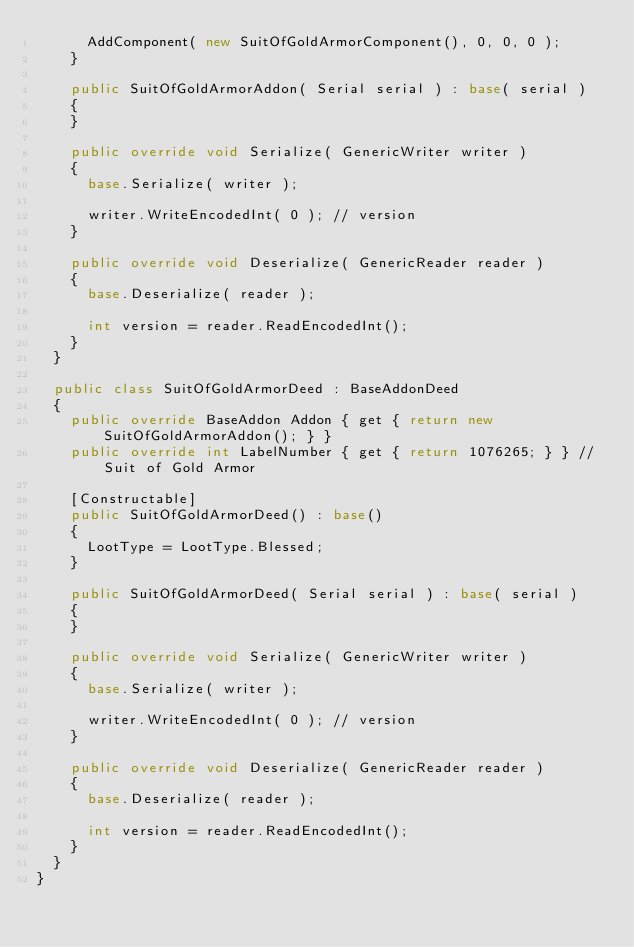<code> <loc_0><loc_0><loc_500><loc_500><_C#_>			AddComponent( new SuitOfGoldArmorComponent(), 0, 0, 0 );
		}

		public SuitOfGoldArmorAddon( Serial serial ) : base( serial )
		{
		}

		public override void Serialize( GenericWriter writer )
		{
			base.Serialize( writer );

			writer.WriteEncodedInt( 0 ); // version
		}

		public override void Deserialize( GenericReader reader )
		{
			base.Deserialize( reader );

			int version = reader.ReadEncodedInt();
		}
	}

	public class SuitOfGoldArmorDeed : BaseAddonDeed
	{
		public override BaseAddon Addon { get { return new SuitOfGoldArmorAddon(); } }
		public override int LabelNumber { get { return 1076265; } } // Suit of Gold Armor

		[Constructable]
		public SuitOfGoldArmorDeed() : base()
		{
			LootType = LootType.Blessed;
		}

		public SuitOfGoldArmorDeed( Serial serial ) : base( serial )
		{
		}

		public override void Serialize( GenericWriter writer )
		{
			base.Serialize( writer );

			writer.WriteEncodedInt( 0 ); // version
		}

		public override void Deserialize( GenericReader reader )
		{
			base.Deserialize( reader );

			int version = reader.ReadEncodedInt();
		}
	}
}
</code> 